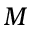<formula> <loc_0><loc_0><loc_500><loc_500>M</formula> 